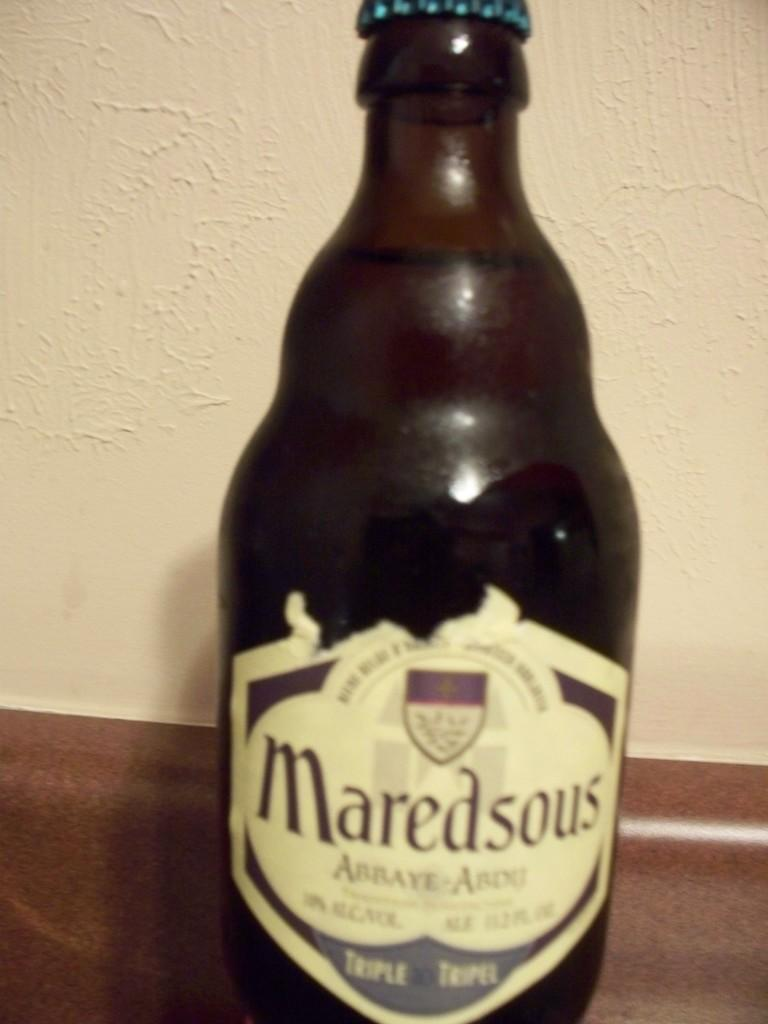Provide a one-sentence caption for the provided image. Maredsous alcohol that is new and sitting on a counter. 